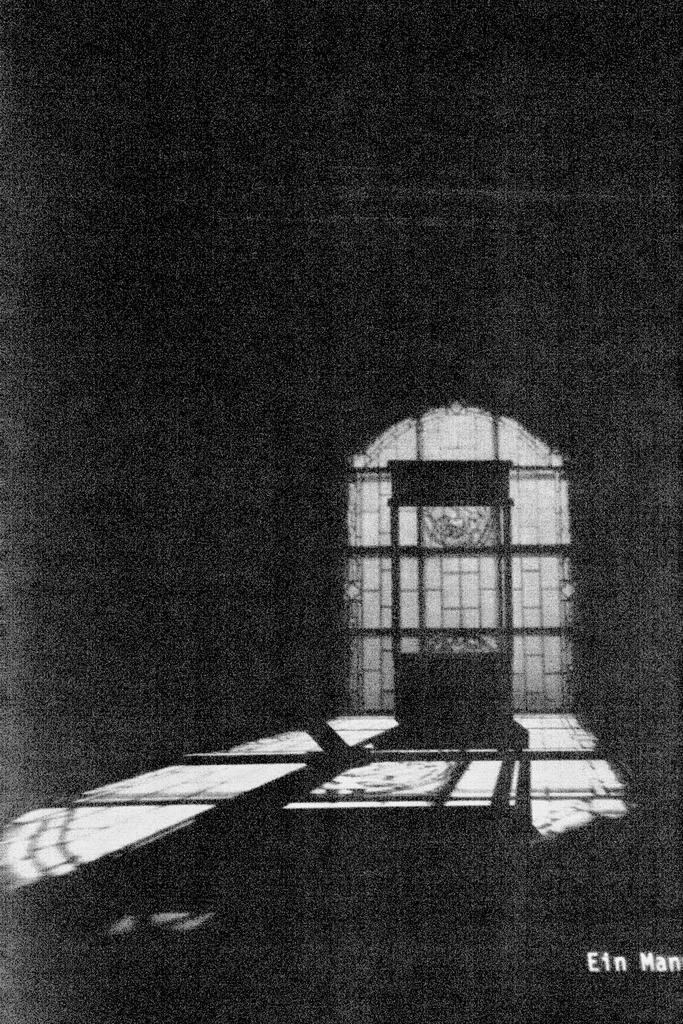In one or two sentences, can you explain what this image depicts? This is a black and white picture. In this picture we can see gate and grills. At the top it is dark. 